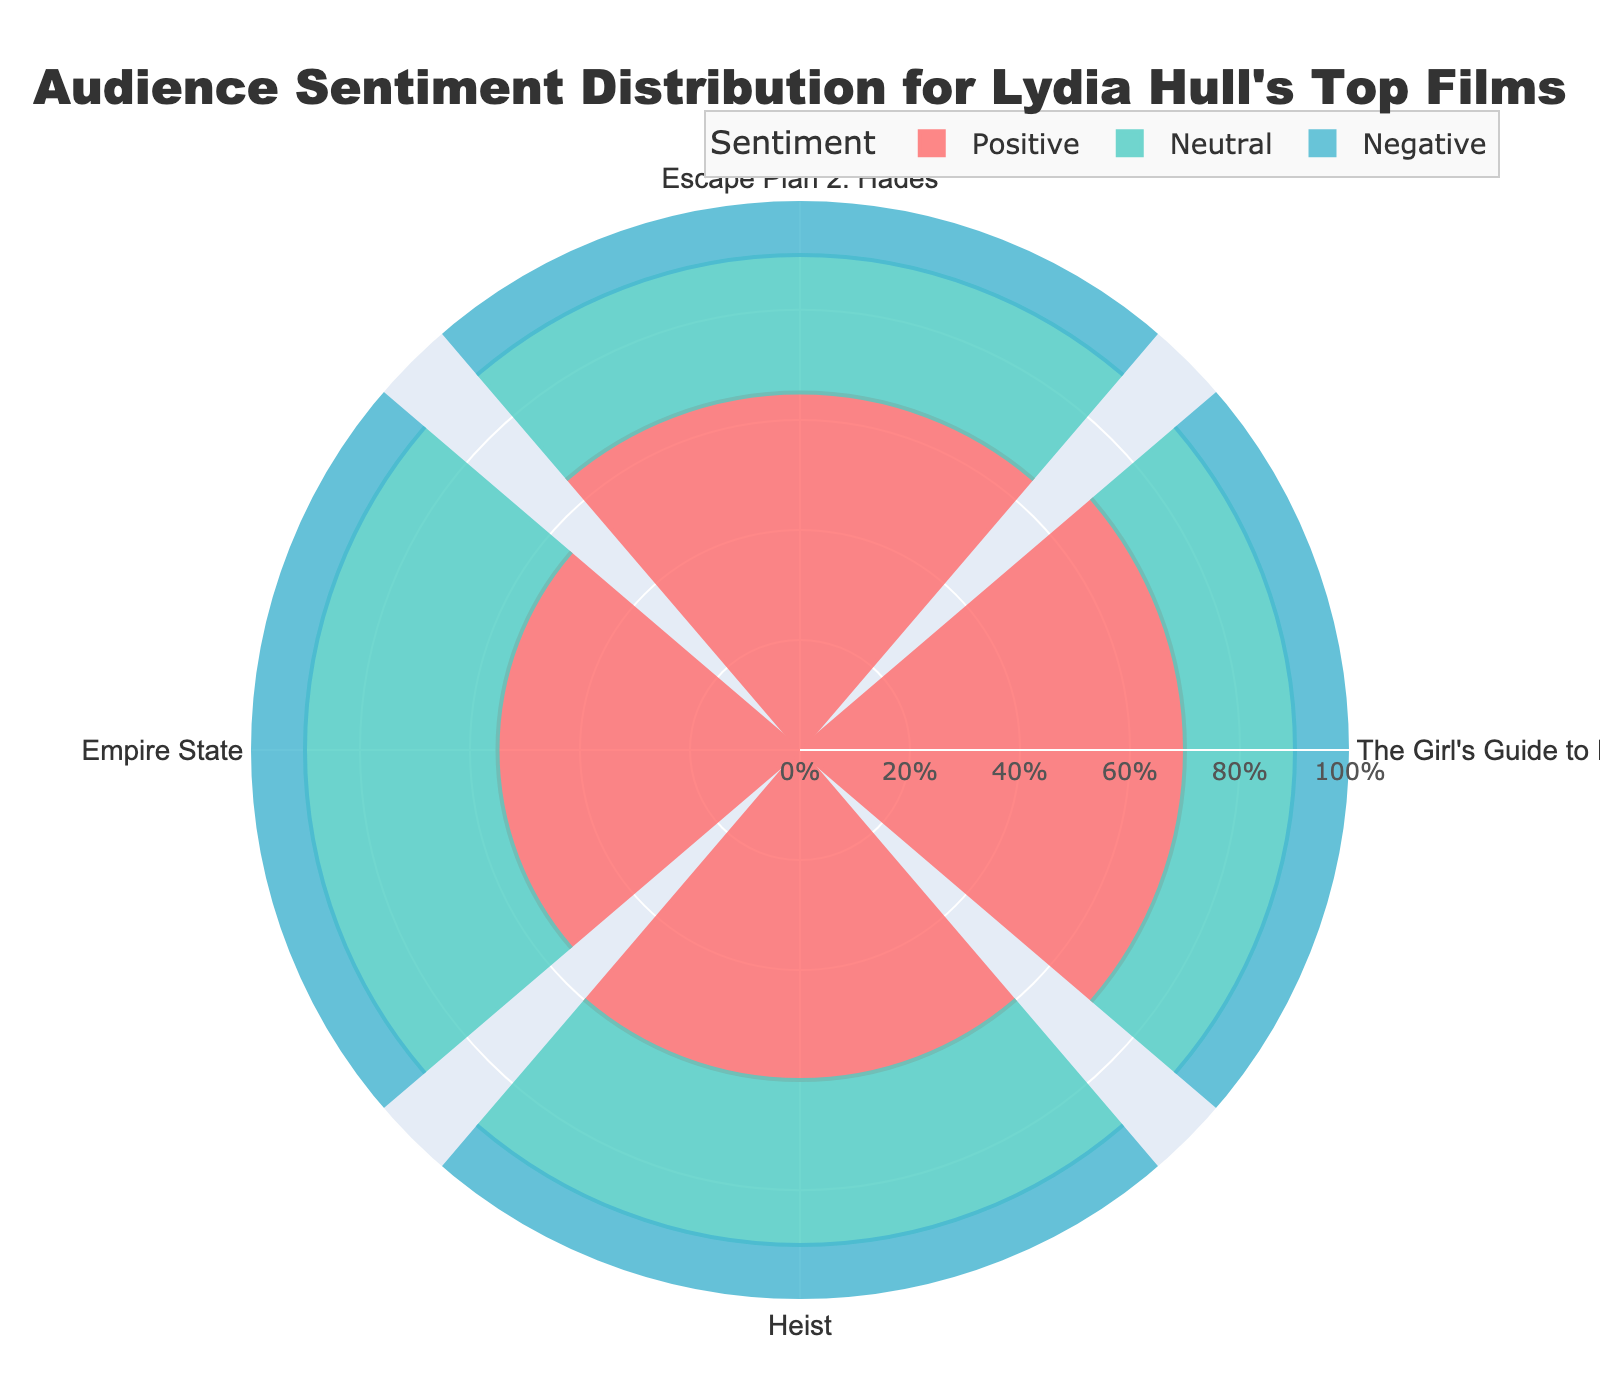What's the title of the figure? The title is usually displayed prominently at the top of the figure, often in a larger font size and distinct color to catch the viewer's attention. In this case, it reads "Audience Sentiment Distribution for Lydia Hull's Top Films".
Answer: Audience Sentiment Distribution for Lydia Hull's Top Films How many films are represented in the rose chart? The rose chart uses the angular axis to represent different groups, which in this case are the film names. Counting the segments, there are four distinct films shown.
Answer: Four Which film has the highest positive sentiment? The length of the bars in the "Positive" section indicates the percentage of positive sentiment for each film. The bar for "The Girl's Guide to Depravity" is the longest, indicating the highest positive sentiment of 70%.
Answer: The Girl's Guide to Depravity What is the approximate average positive sentiment across all films? To find the average, sum the positive sentiment percentages for all films (65 + 70 + 60 + 55) and then divide by the number of films, which is 4. This average is (65 + 70 + 60 + 55) / 4 = 62.5%.
Answer: 62.5% How does the neutral sentiment for "Heist" compare to that for "Empire State"? By looking at the lengths of the bars in the "Neutral" section for both films, "Empire State" (35%) has a higher neutral sentiment than "Heist" (30%).
Answer: Empire State has higher neutral sentiment For which sentiment type do all films have exactly the same value? By visually comparing the lengths of the bars under each sentiment type, all the films show a consistent bar length of 10% under "Negative".
Answer: Negative What's the range of positive sentiment observed in these films? The range is found by subtracting the smallest positive sentiment percentage (55% for "Empire State") from the largest (70% for "The Girl's Guide to Depravity"), which gives 70 - 55 = 15%.
Answer: 15% What percentage of sentiments for "Escape Plan 2: Hades" are not positive? First, sum the neutral and negative sentiments for the film "Escape Plan 2: Hades" to find the total percentage that is not positive. This is 25% (neutral) + 10% (negative) = 35%.
Answer: 35% Which film has the lowest neutral sentiment? By comparing the lengths of the bars in the "Neutral" section of the chart, "The Girl's Guide to Depravity" has the shortest bar for neutral sentiment, indicating the lowest value of 20%.
Answer: The Girl's Guide to Depravity 